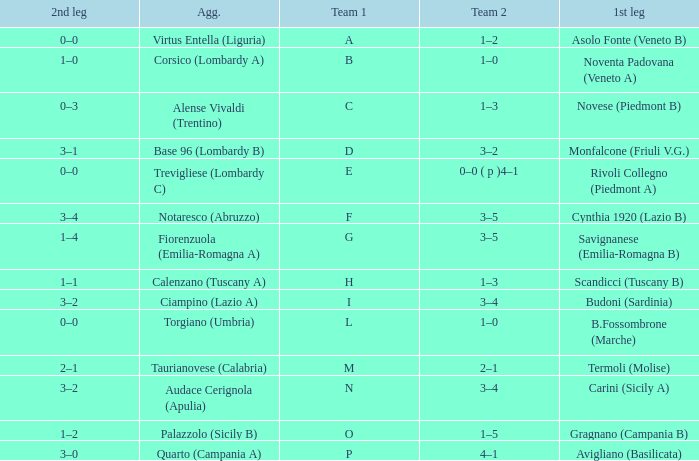What 1st leg has Alense Vivaldi (Trentino) as Agg.? Novese (Piedmont B). 